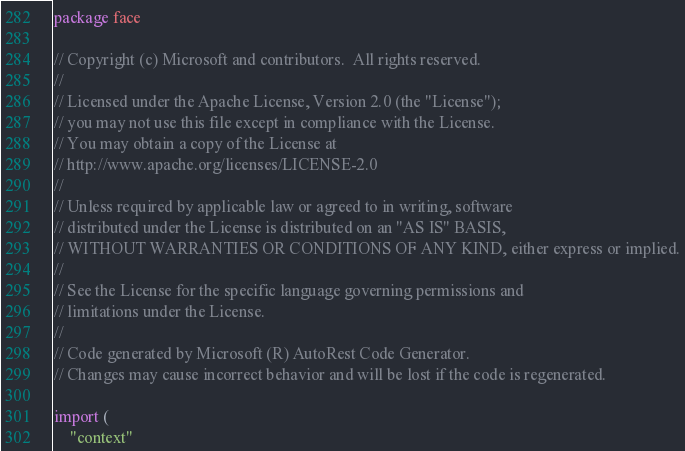Convert code to text. <code><loc_0><loc_0><loc_500><loc_500><_Go_>package face

// Copyright (c) Microsoft and contributors.  All rights reserved.
//
// Licensed under the Apache License, Version 2.0 (the "License");
// you may not use this file except in compliance with the License.
// You may obtain a copy of the License at
// http://www.apache.org/licenses/LICENSE-2.0
//
// Unless required by applicable law or agreed to in writing, software
// distributed under the License is distributed on an "AS IS" BASIS,
// WITHOUT WARRANTIES OR CONDITIONS OF ANY KIND, either express or implied.
//
// See the License for the specific language governing permissions and
// limitations under the License.
//
// Code generated by Microsoft (R) AutoRest Code Generator.
// Changes may cause incorrect behavior and will be lost if the code is regenerated.

import (
	"context"</code> 